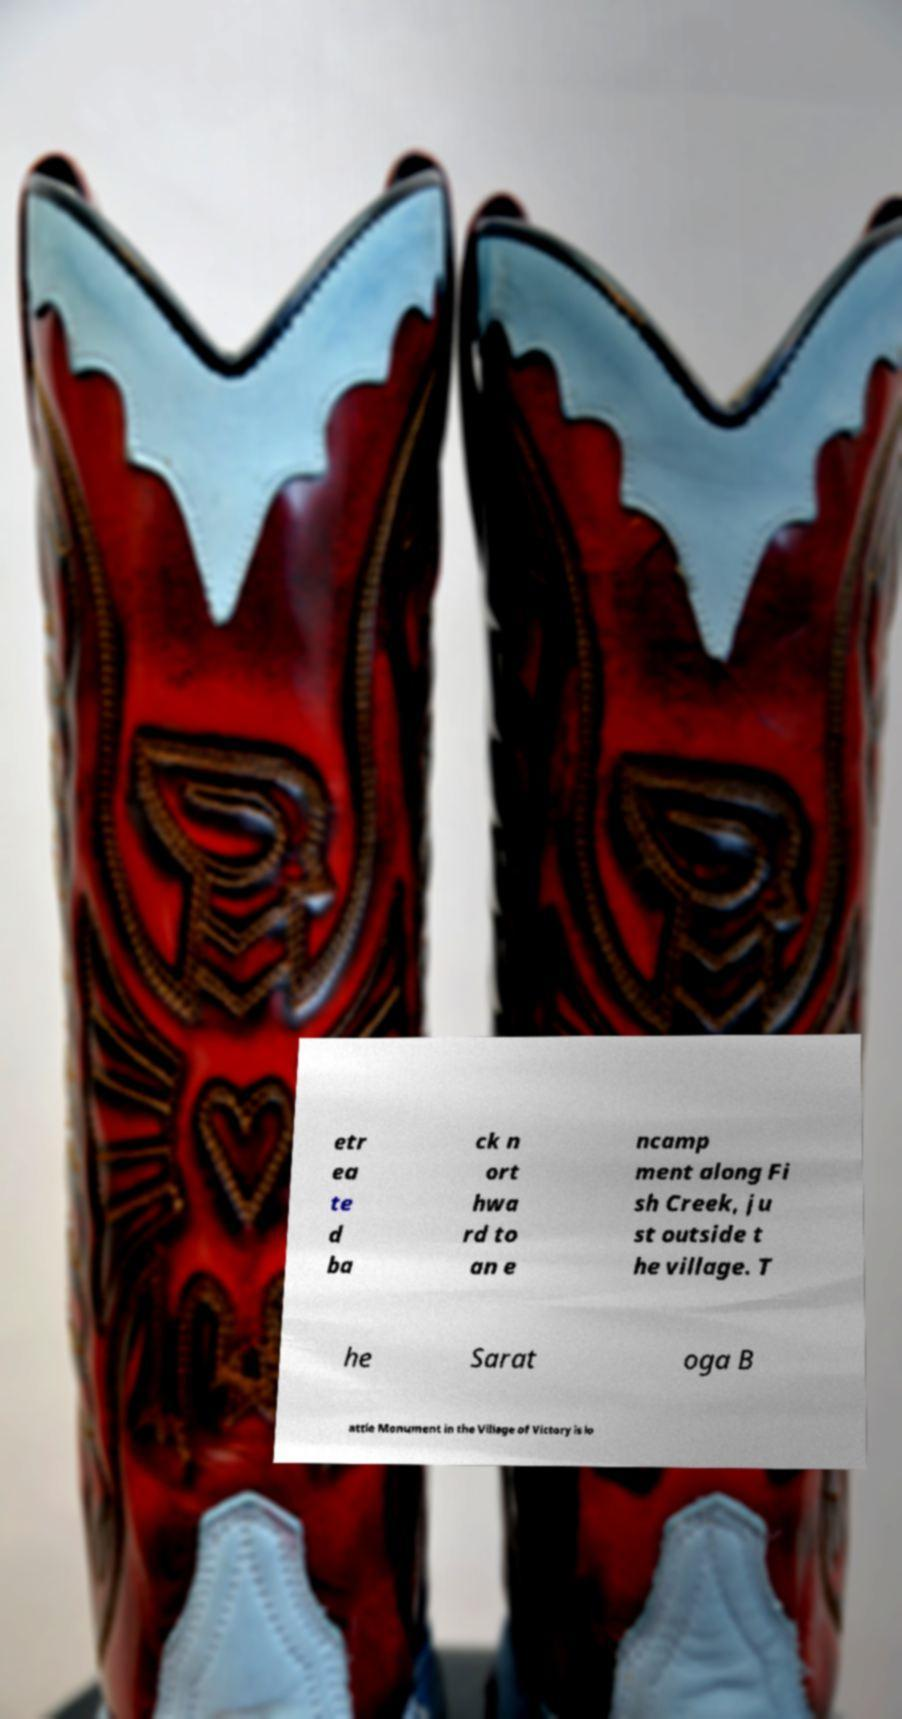I need the written content from this picture converted into text. Can you do that? etr ea te d ba ck n ort hwa rd to an e ncamp ment along Fi sh Creek, ju st outside t he village. T he Sarat oga B attle Monument in the Village of Victory is lo 